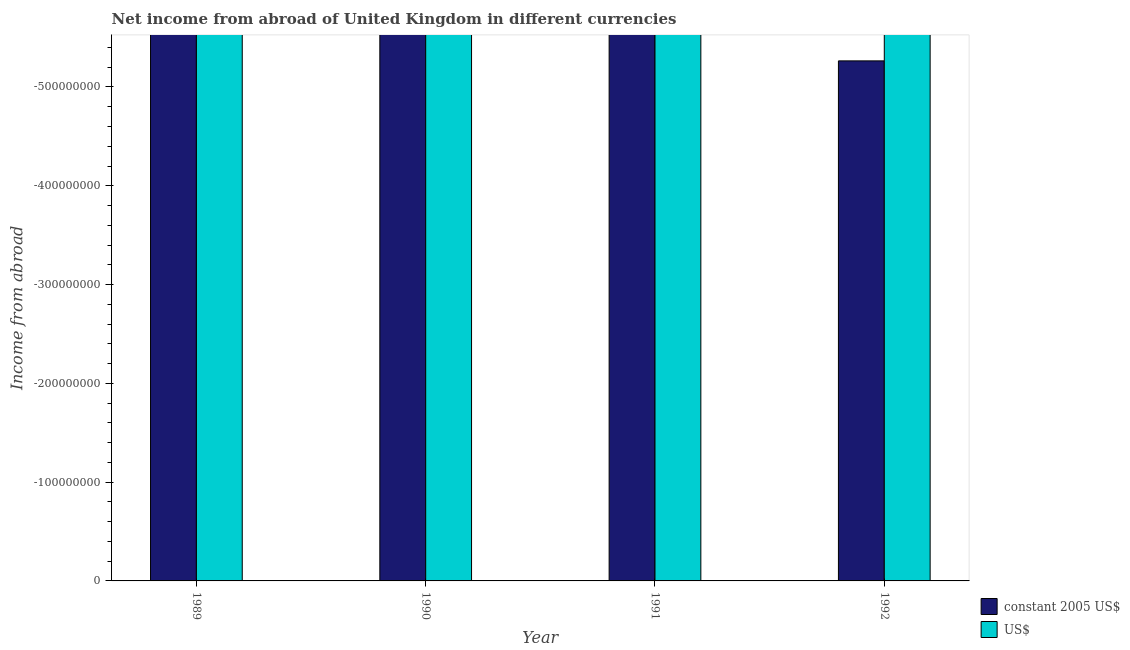How many bars are there on the 2nd tick from the left?
Provide a short and direct response. 0. In how many cases, is the number of bars for a given year not equal to the number of legend labels?
Your response must be concise. 4. What is the income from abroad in us$ in 1989?
Give a very brief answer. 0. Across all years, what is the minimum income from abroad in us$?
Give a very brief answer. 0. What is the total income from abroad in constant 2005 us$ in the graph?
Provide a succinct answer. 0. What is the difference between the income from abroad in us$ in 1991 and the income from abroad in constant 2005 us$ in 1992?
Provide a short and direct response. 0. How many bars are there?
Your answer should be compact. 0. Are the values on the major ticks of Y-axis written in scientific E-notation?
Offer a terse response. No. Does the graph contain any zero values?
Your response must be concise. Yes. Does the graph contain grids?
Give a very brief answer. No. Where does the legend appear in the graph?
Your response must be concise. Bottom right. How many legend labels are there?
Your answer should be very brief. 2. What is the title of the graph?
Give a very brief answer. Net income from abroad of United Kingdom in different currencies. Does "Male" appear as one of the legend labels in the graph?
Provide a succinct answer. No. What is the label or title of the X-axis?
Provide a short and direct response. Year. What is the label or title of the Y-axis?
Your answer should be compact. Income from abroad. What is the Income from abroad in constant 2005 US$ in 1989?
Offer a terse response. 0. What is the Income from abroad in US$ in 1989?
Offer a very short reply. 0. What is the Income from abroad of constant 2005 US$ in 1991?
Your answer should be very brief. 0. What is the Income from abroad in US$ in 1991?
Your response must be concise. 0. What is the average Income from abroad in US$ per year?
Your answer should be very brief. 0. 